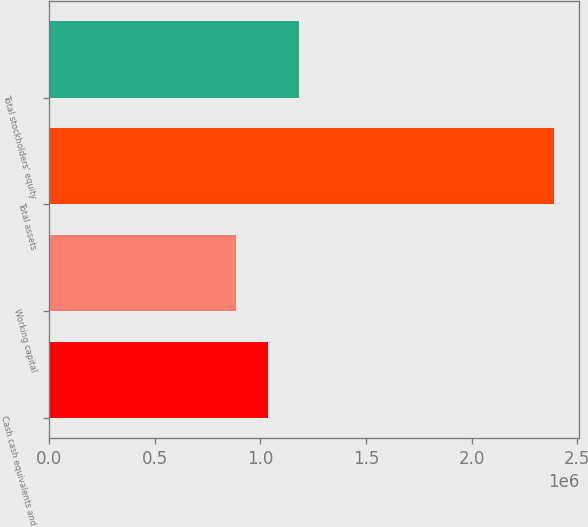Convert chart. <chart><loc_0><loc_0><loc_500><loc_500><bar_chart><fcel>Cash cash equivalents and<fcel>Working capital<fcel>Total assets<fcel>Total stockholders' equity<nl><fcel>1.0344e+06<fcel>883829<fcel>2.38959e+06<fcel>1.18498e+06<nl></chart> 